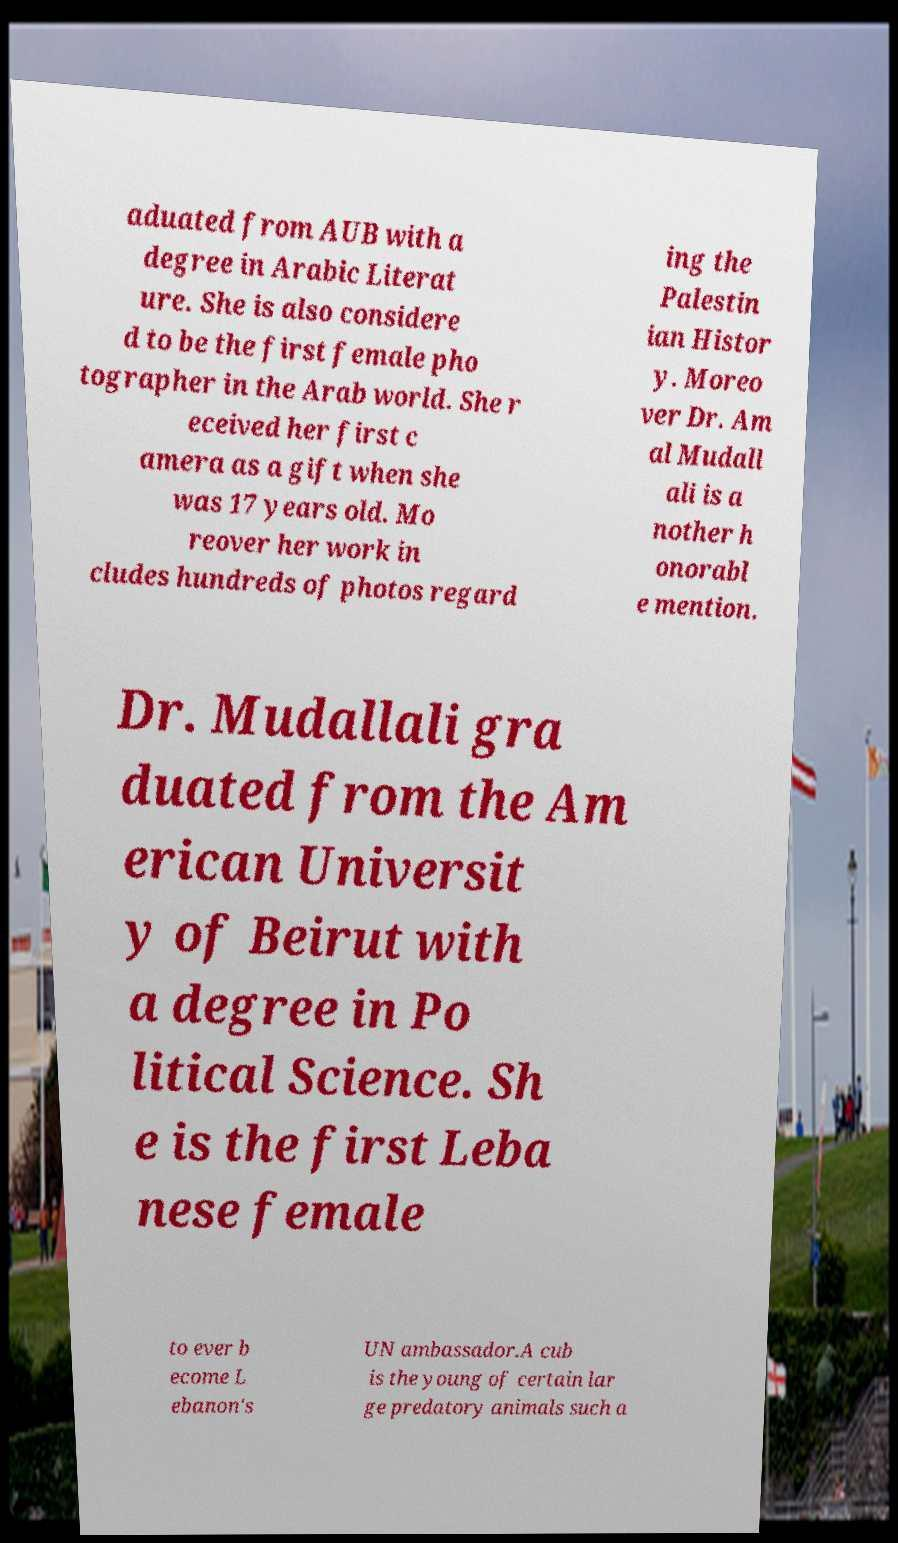What messages or text are displayed in this image? I need them in a readable, typed format. aduated from AUB with a degree in Arabic Literat ure. She is also considere d to be the first female pho tographer in the Arab world. She r eceived her first c amera as a gift when she was 17 years old. Mo reover her work in cludes hundreds of photos regard ing the Palestin ian Histor y. Moreo ver Dr. Am al Mudall ali is a nother h onorabl e mention. Dr. Mudallali gra duated from the Am erican Universit y of Beirut with a degree in Po litical Science. Sh e is the first Leba nese female to ever b ecome L ebanon's UN ambassador.A cub is the young of certain lar ge predatory animals such a 